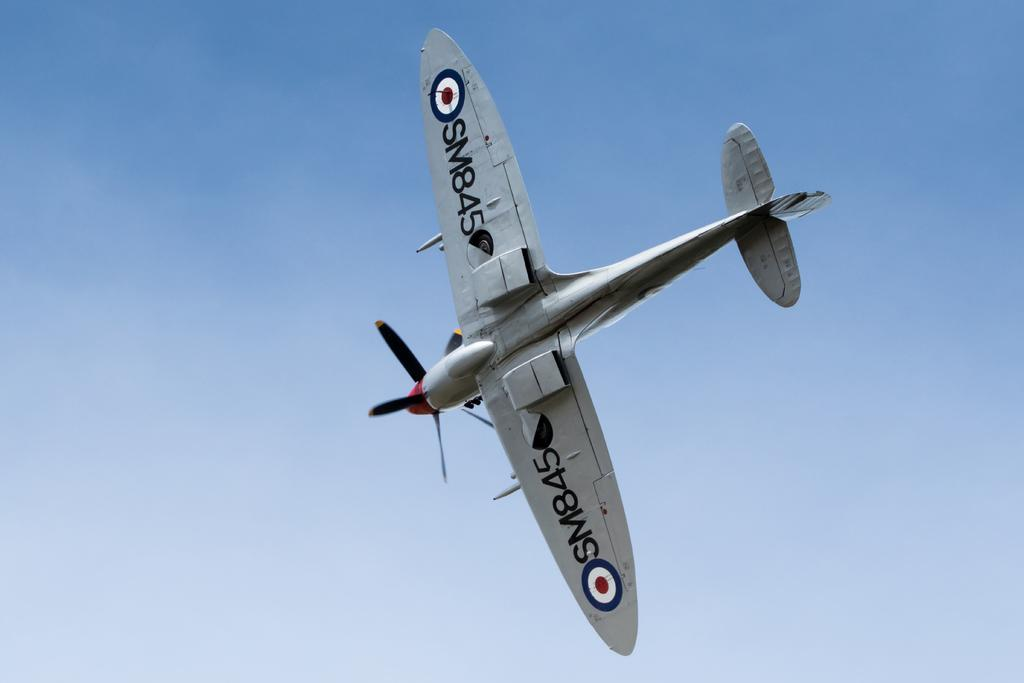<image>
Present a compact description of the photo's key features. A small, grey airplane flying in the sky with SM845 written on the bottom of both wings. 